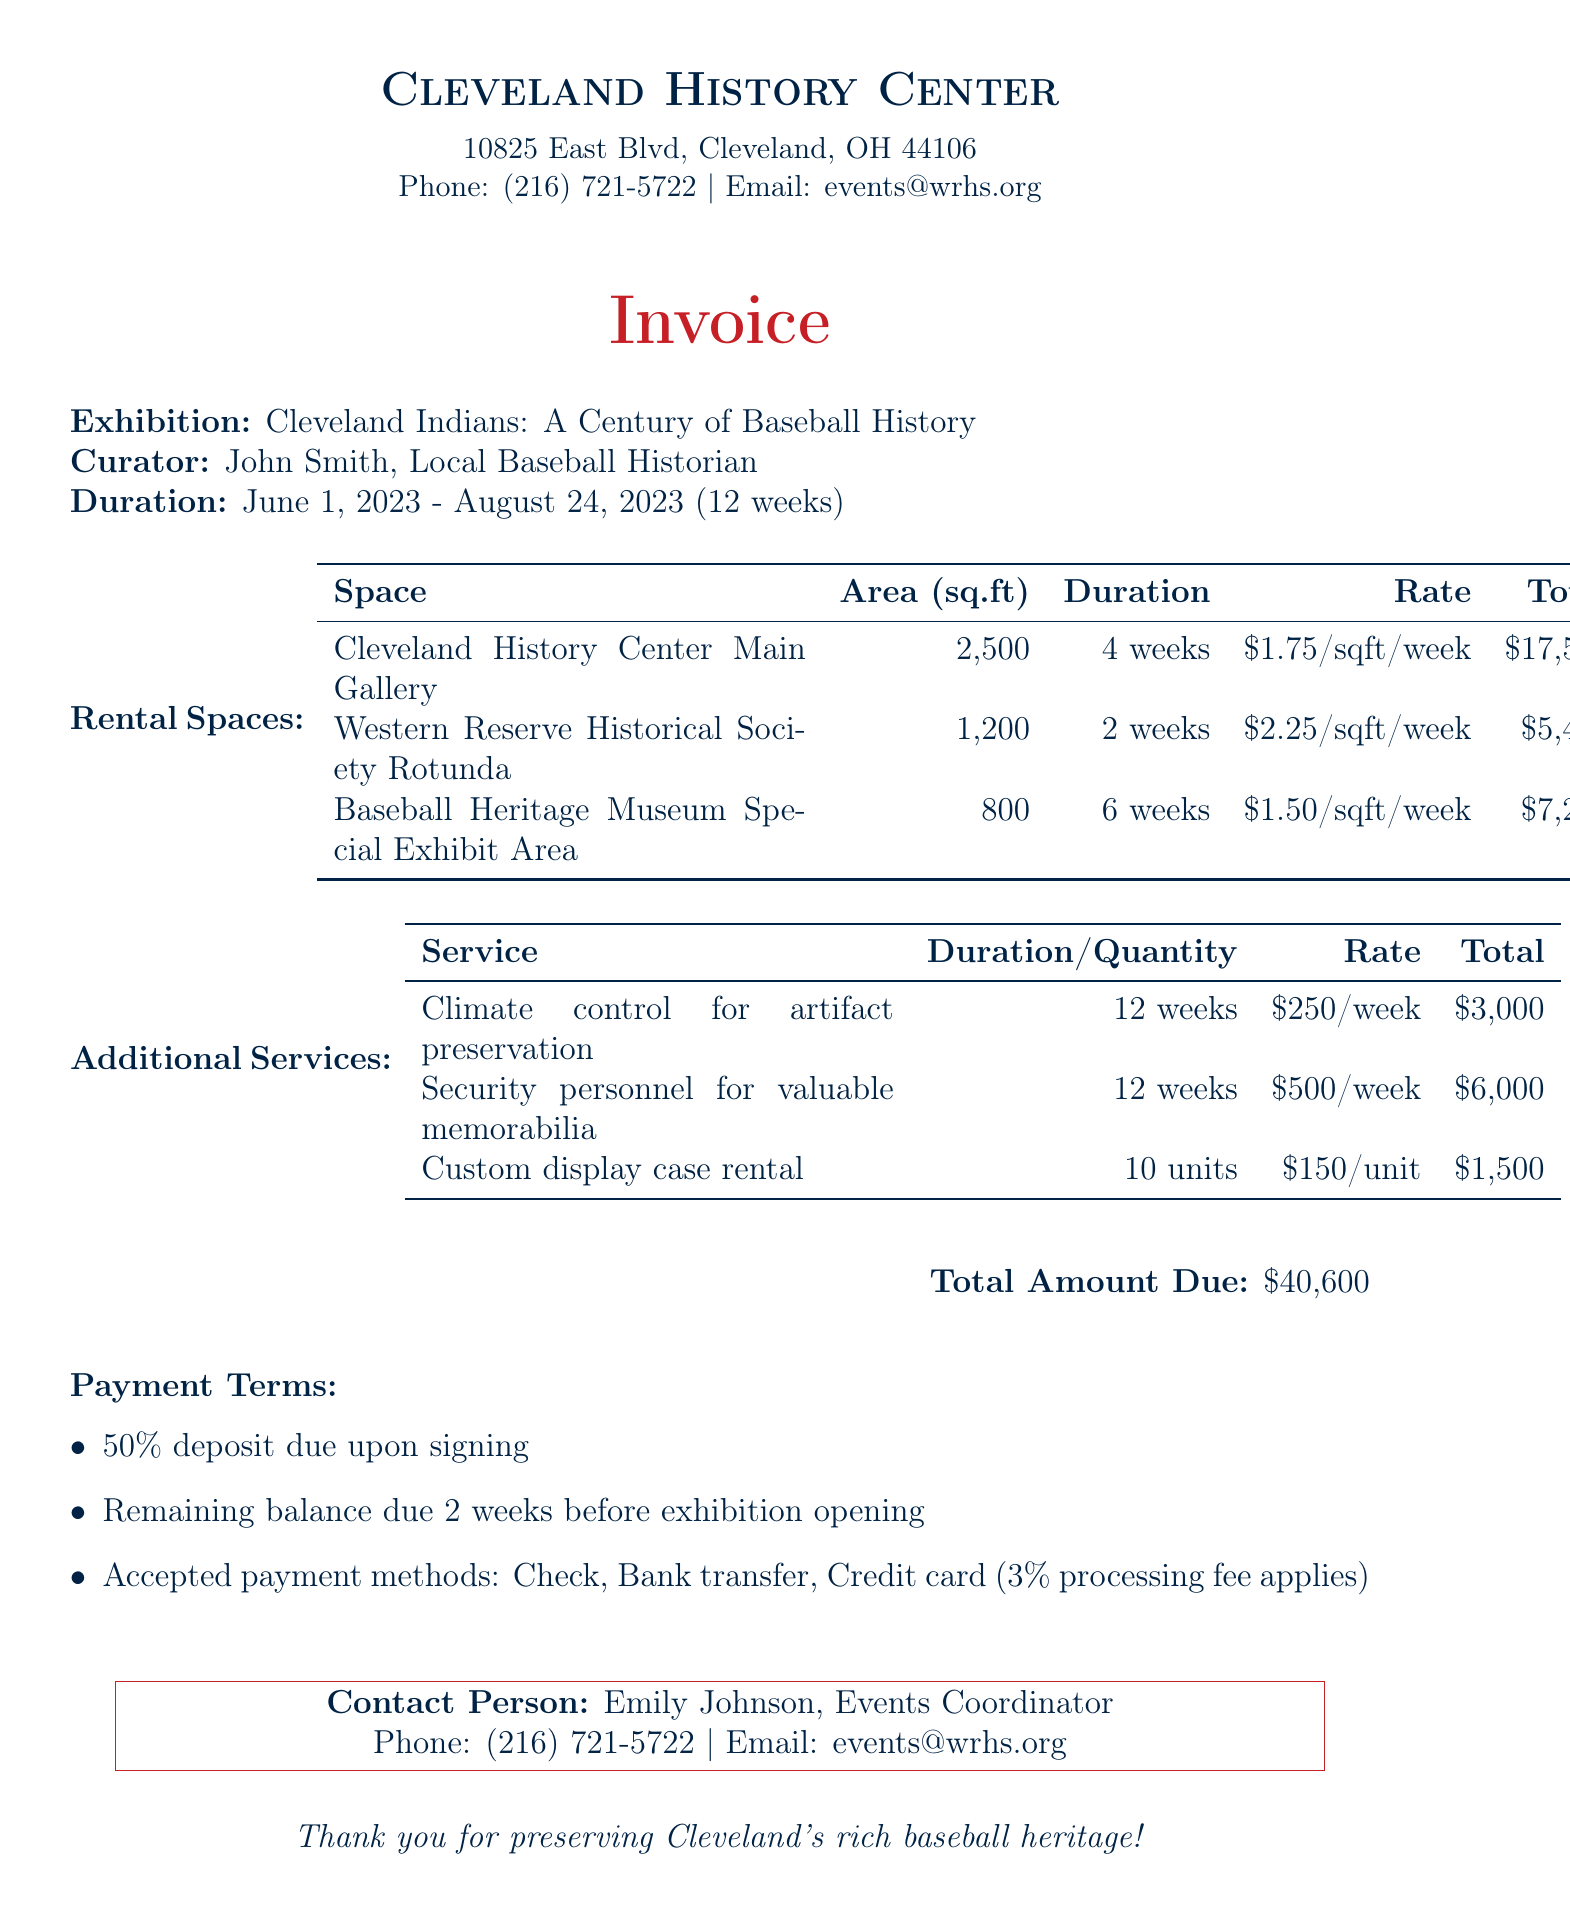What is the total amount due? The total amount due is clearly stated at the bottom of the invoice.
Answer: $40,600 Who is the curator of the exhibition? The curator's name is mentioned prominently in the exhibition details.
Answer: John Smith What is the square footage of the Cleveland History Center Main Gallery? This information is listed in the rental spaces section for each space.
Answer: 2500 How many weeks is the Baseball Heritage Museum Special Exhibit Area rented for? The duration for this specific space is provided in the table of rental spaces.
Answer: 6 weeks What is the cost per week for climate control for artifact preservation? The cost per week for this additional service is indicated in the additional services table.
Answer: $250 How many units of custom display case rental are included? The quantity of these units is specifically stated in the additional services section.
Answer: 10 What is the contact person's name at the museum? The document provides a contact person’s name at the end of the invoice.
Answer: Emily Johnson What is the duration of the exhibition? The total duration of the exhibition is given in the exhibition details section.
Answer: 12 weeks What percentage of the total amount is the deposit due upon signing? This specific percentage is mentioned in the payment terms of the invoice.
Answer: 50% 